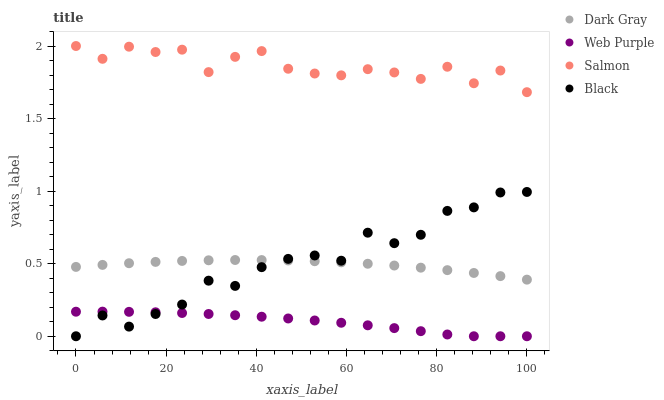Does Web Purple have the minimum area under the curve?
Answer yes or no. Yes. Does Salmon have the maximum area under the curve?
Answer yes or no. Yes. Does Black have the minimum area under the curve?
Answer yes or no. No. Does Black have the maximum area under the curve?
Answer yes or no. No. Is Dark Gray the smoothest?
Answer yes or no. Yes. Is Black the roughest?
Answer yes or no. Yes. Is Web Purple the smoothest?
Answer yes or no. No. Is Web Purple the roughest?
Answer yes or no. No. Does Black have the lowest value?
Answer yes or no. Yes. Does Salmon have the lowest value?
Answer yes or no. No. Does Salmon have the highest value?
Answer yes or no. Yes. Does Black have the highest value?
Answer yes or no. No. Is Web Purple less than Dark Gray?
Answer yes or no. Yes. Is Salmon greater than Web Purple?
Answer yes or no. Yes. Does Dark Gray intersect Black?
Answer yes or no. Yes. Is Dark Gray less than Black?
Answer yes or no. No. Is Dark Gray greater than Black?
Answer yes or no. No. Does Web Purple intersect Dark Gray?
Answer yes or no. No. 